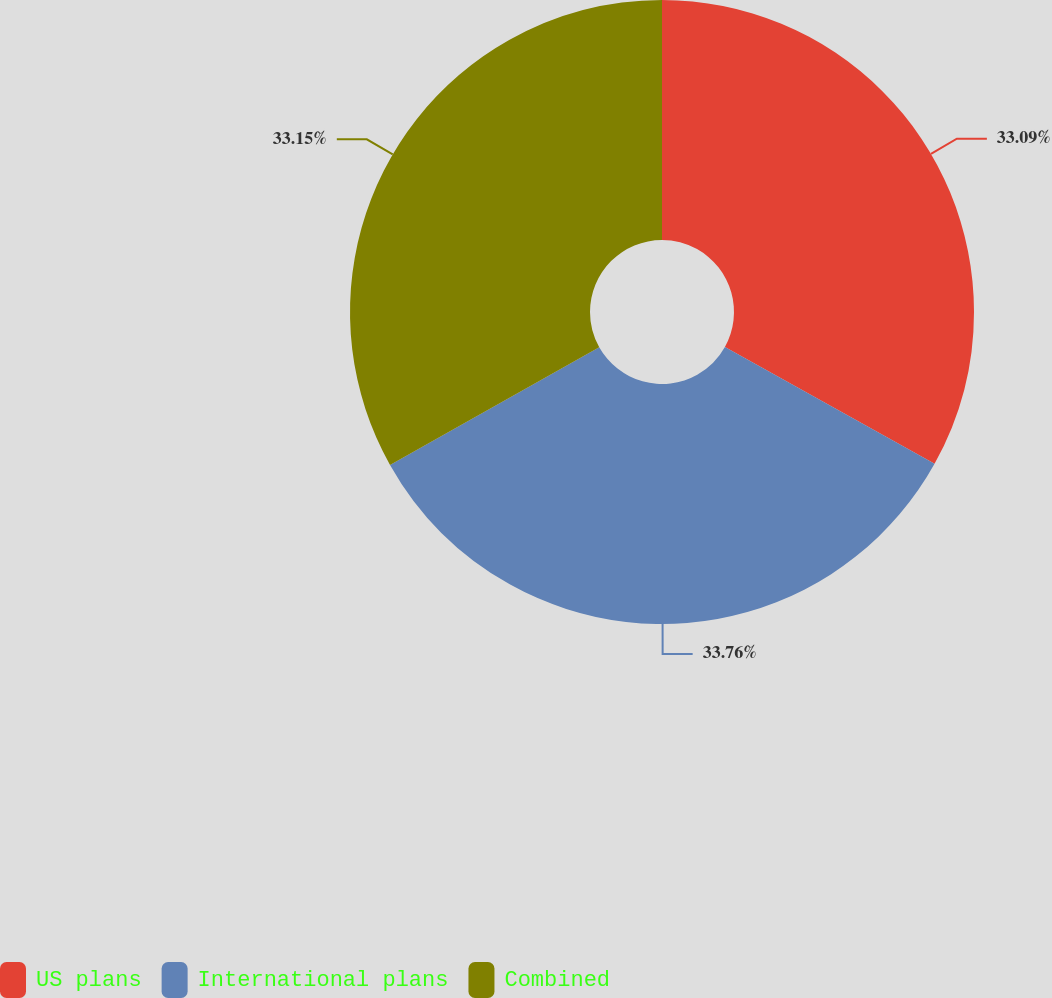<chart> <loc_0><loc_0><loc_500><loc_500><pie_chart><fcel>US plans<fcel>International plans<fcel>Combined<nl><fcel>33.09%<fcel>33.76%<fcel>33.15%<nl></chart> 